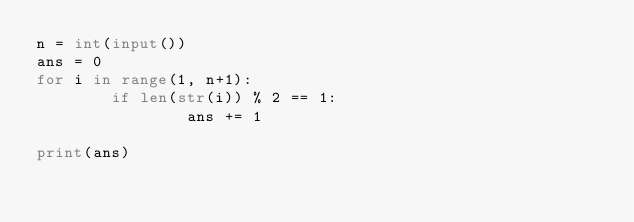<code> <loc_0><loc_0><loc_500><loc_500><_Python_>n = int(input())
ans = 0
for i in range(1, n+1):
        if len(str(i)) % 2 == 1:
                ans += 1

print(ans)</code> 